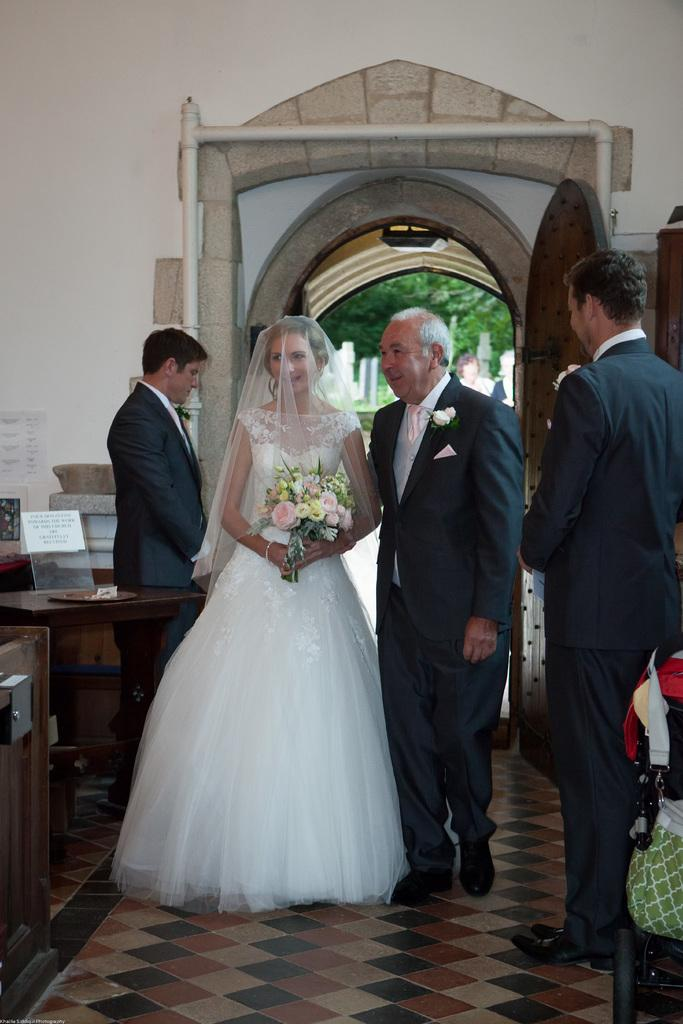What are the persons in the image doing? The persons in the image are on the floor. What can be seen in the background of the image? There is a door and trees visible in the background of the image. Where are the tables located in the image? There are tables on both the right and left sides of the image. What type of fiction is the servant reading in the image? There is no servant or fiction present in the image. 